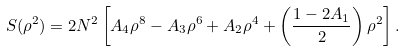Convert formula to latex. <formula><loc_0><loc_0><loc_500><loc_500>S ( \rho ^ { 2 } ) = 2 N ^ { 2 } \left [ A _ { 4 } \rho ^ { 8 } - A _ { 3 } \rho ^ { 6 } + A _ { 2 } \rho ^ { 4 } + \left ( \frac { 1 - 2 A _ { 1 } } { 2 } \right ) \rho ^ { 2 } \right ] .</formula> 